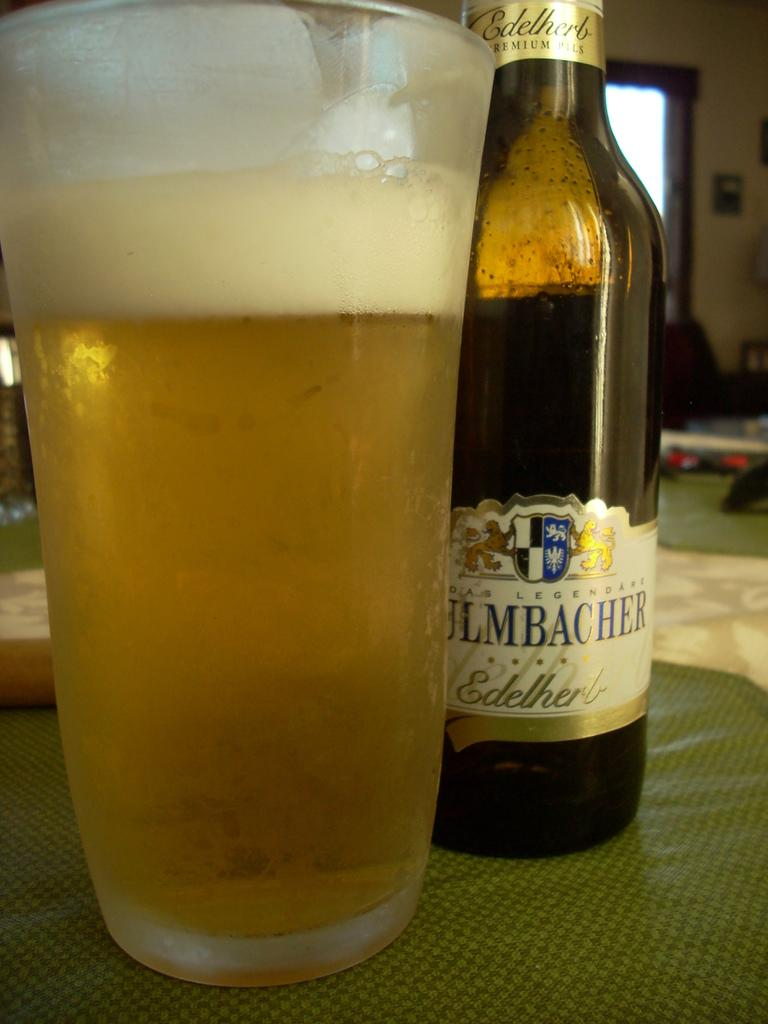Provide a one-sentence caption for the provided image. the half leveled edelherb premium pills bottle which placed back to the glass of beer. 